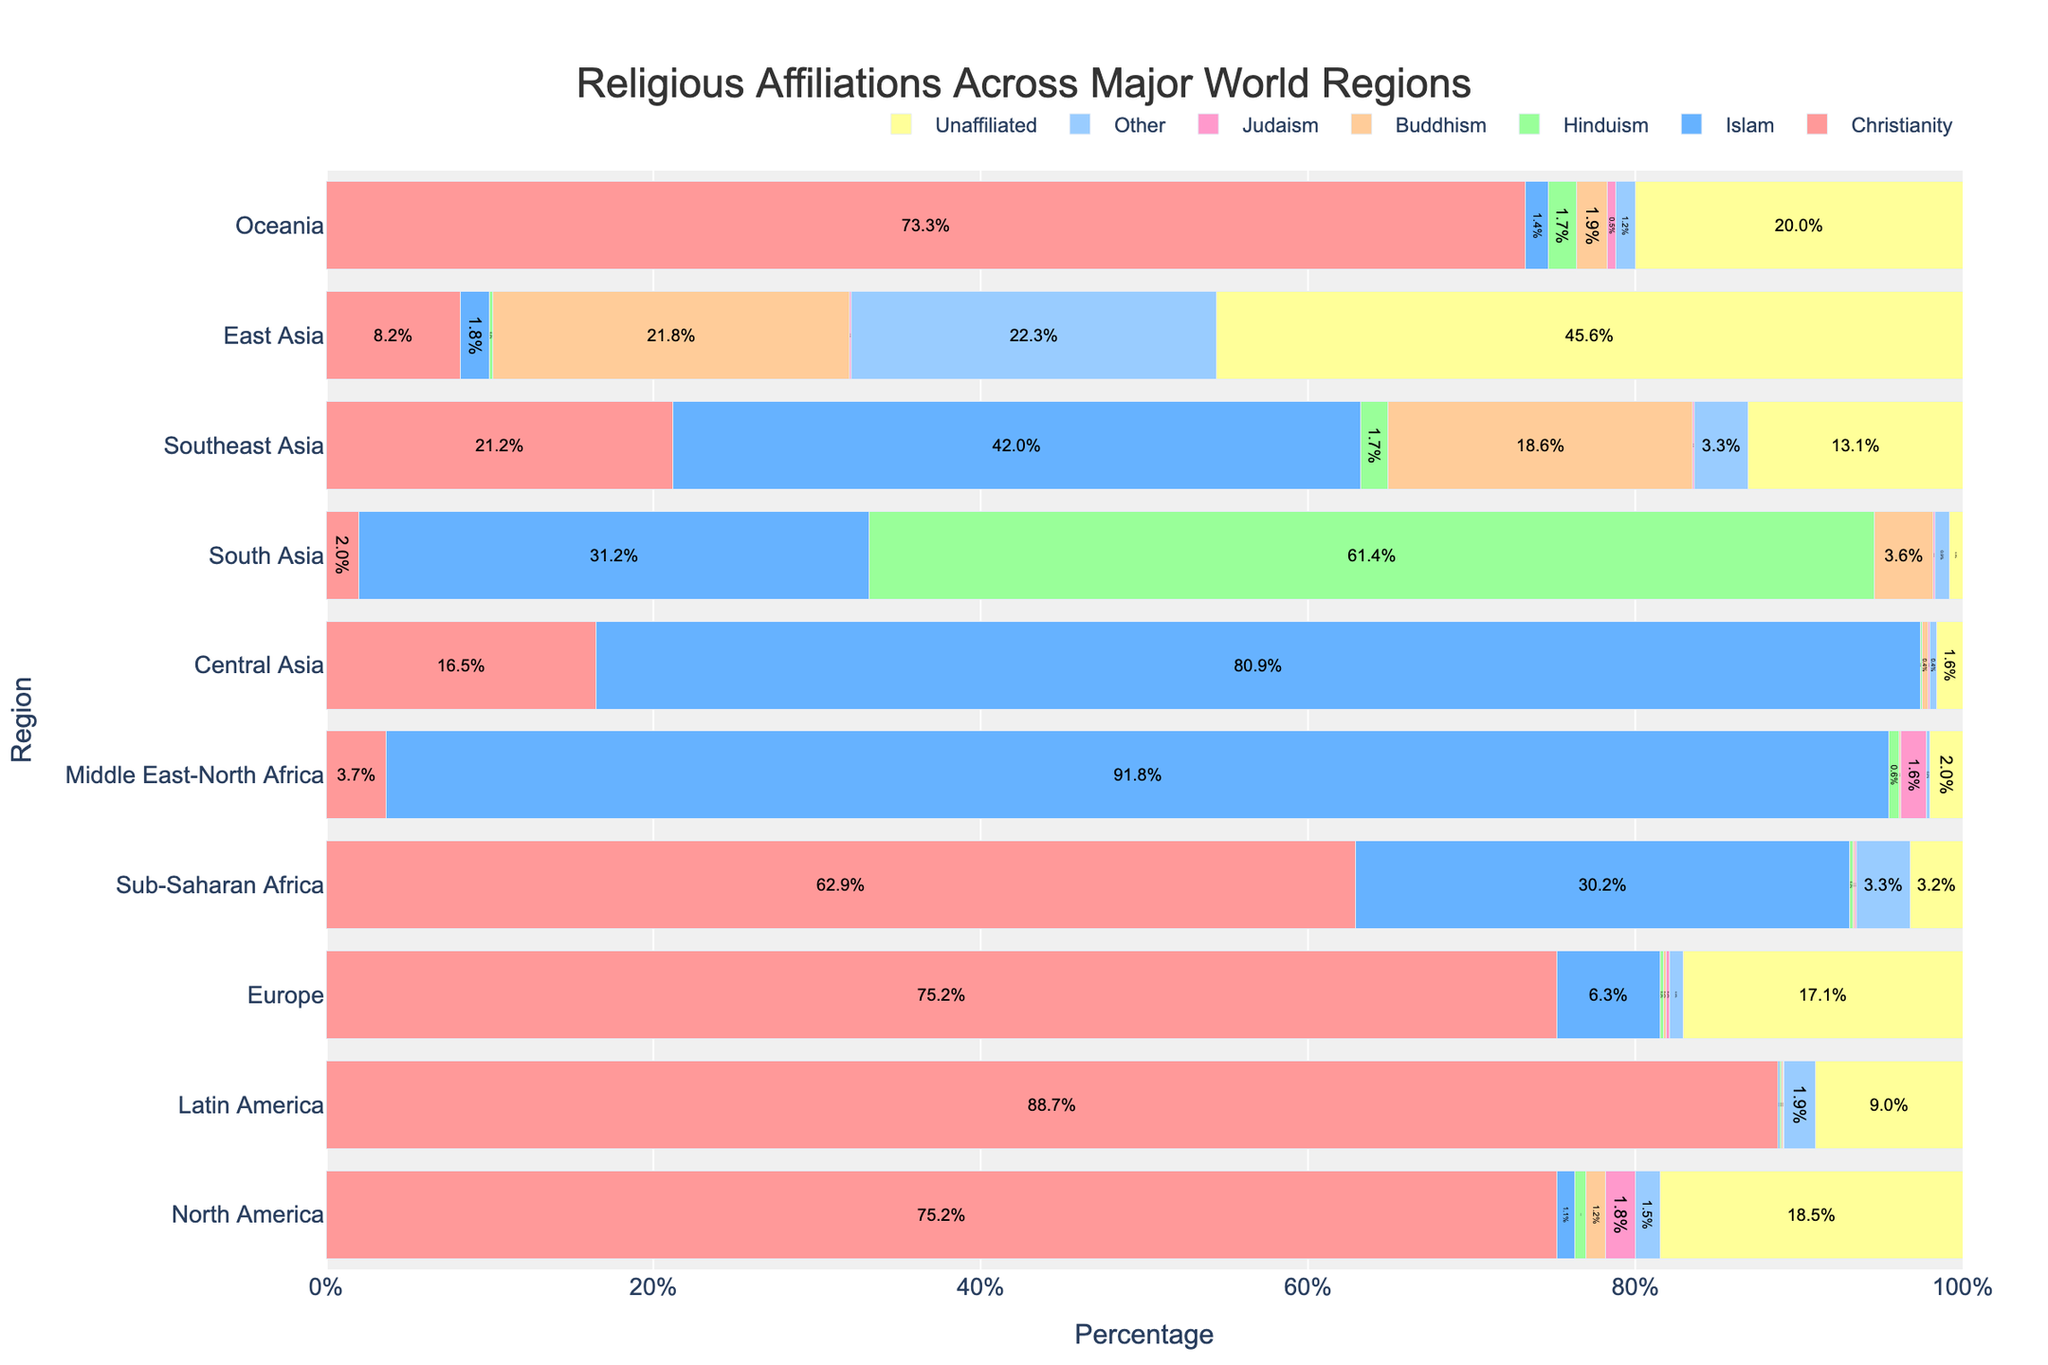What's the dominant religion in Sub-Saharan Africa? By inspecting the bars for Sub-Saharan Africa, the largest proportion of the bar belongs to Christianity at 62.9%, indicating it is the dominant religion.
Answer: Christianity Which region has the highest percentage of people identifying as 'Unaffiliated'? By comparing the lengths of the 'Unaffiliated' bars across all regions, East Asia has the longest bar at 45.6%.
Answer: East Asia What is the sum of Christianity and Islam percentages in Central Asia? The bar for Christianity in Central Asia shows 16.5%, and for Islam, it shows 80.9%. Summing these percentages, 16.5 + 80.9 = 97.4%.
Answer: 97.4% In which region is Buddhism most prevalent? Inspecting the bars for Buddhism across all regions, the longest bar is in East Asia, with a percentage of 21.8%.
Answer: East Asia What's the relative difference in Judaism percentage between North America and the Middle East-North Africa? The percentage of Judaism in North America is 1.8%, and in the Middle East-North Africa, it is 1.6%. The difference is 1.8% - 1.6% = 0.2%.
Answer: 0.2% Which region has the lowest percentage of adherents to other religions? By comparing the 'Other' bars across regions, Central Asia has the lowest percentage at 0.4%.
Answer: Central Asia Compare the percentage of Hindus in South Asia and Southeast Asia. Which region has more, and by how much? South Asia has 61.4% Hindus, and Southeast Asia has 1.7%, resulting in South Asia having 61.4 - 1.7 = 59.7% more Hindus.
Answer: South Asia by 59.7% What is the second most common religion in Southeast Asia? In Southeast Asia, the bar for Islam is most common at 42%, followed by Buddhism at 18.6%, making Buddhism the second most common religion.
Answer: Buddhism How does the percentage of unaffiliated individuals in Oceania compare to North America? In Oceania, the percentage of 'Unaffiliated' is 20.0%, while in North America, it is 18.5%. Oceania has 1.5% more.
Answer: Oceania has 1.5% more 